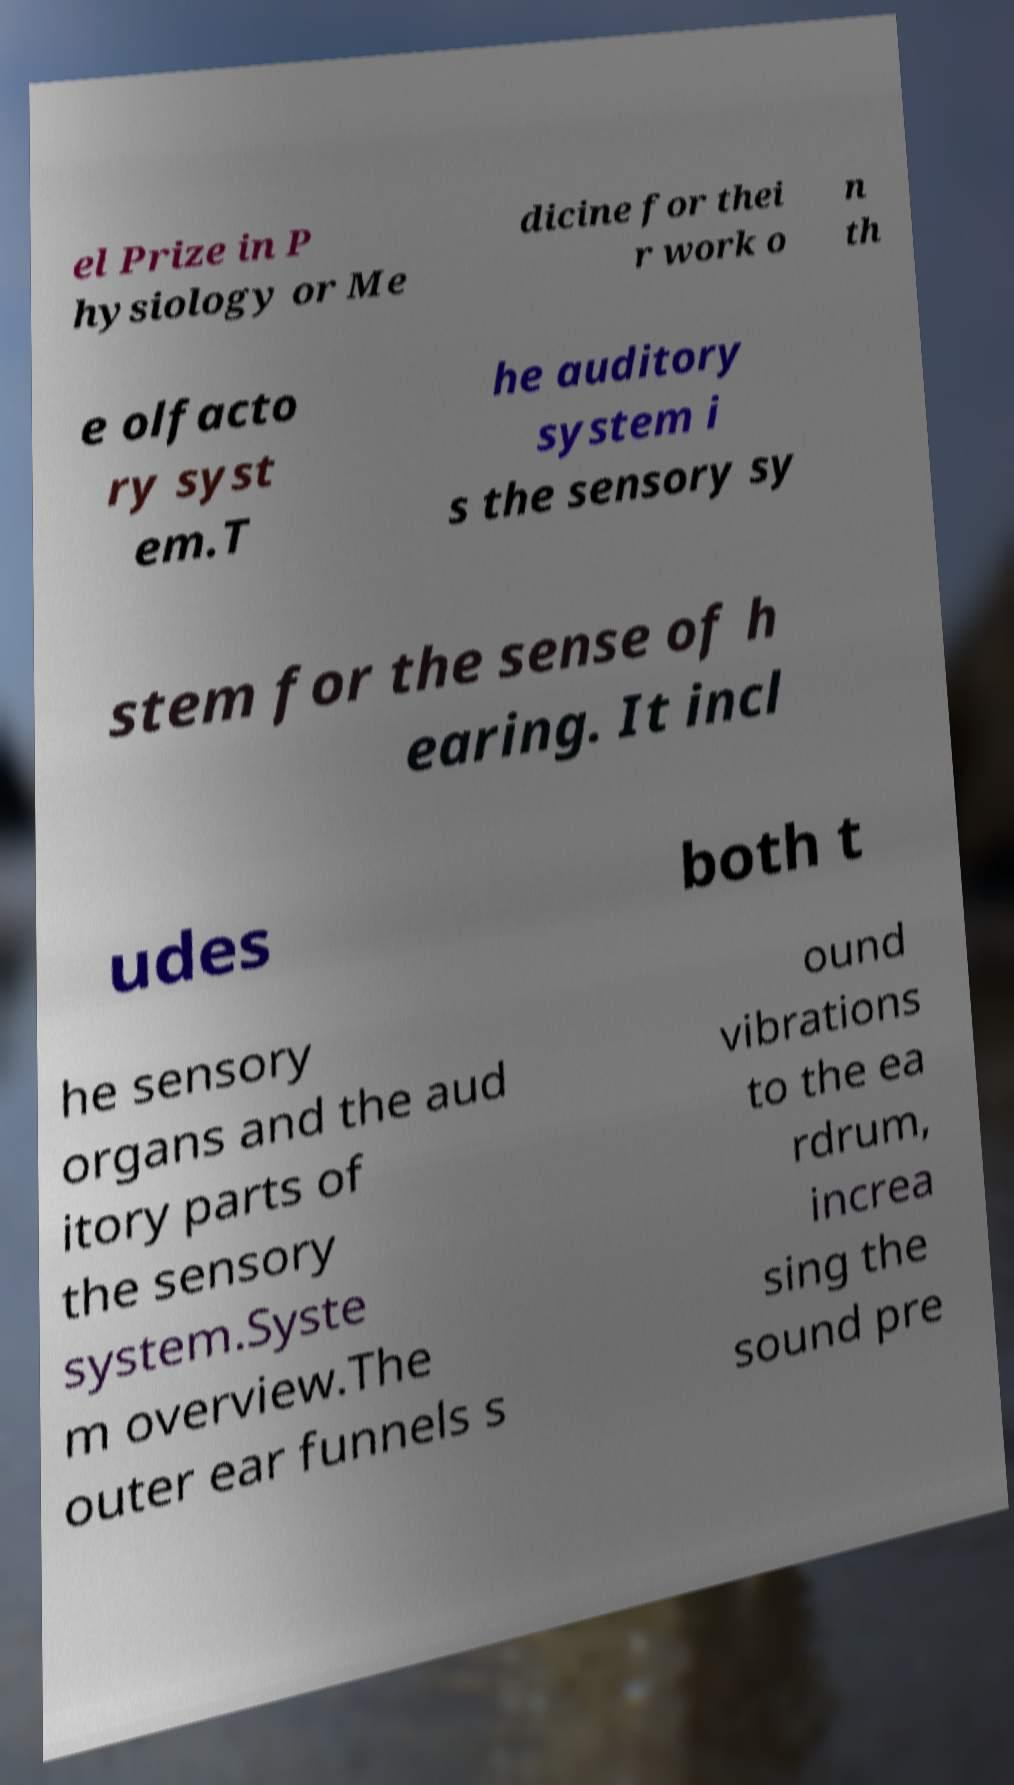Can you read and provide the text displayed in the image?This photo seems to have some interesting text. Can you extract and type it out for me? el Prize in P hysiology or Me dicine for thei r work o n th e olfacto ry syst em.T he auditory system i s the sensory sy stem for the sense of h earing. It incl udes both t he sensory organs and the aud itory parts of the sensory system.Syste m overview.The outer ear funnels s ound vibrations to the ea rdrum, increa sing the sound pre 